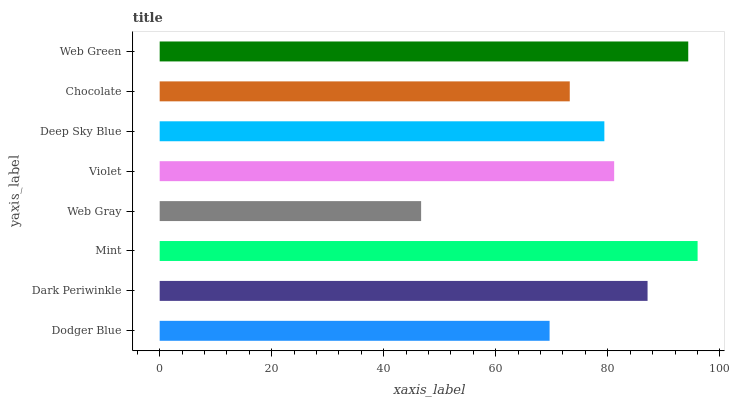Is Web Gray the minimum?
Answer yes or no. Yes. Is Mint the maximum?
Answer yes or no. Yes. Is Dark Periwinkle the minimum?
Answer yes or no. No. Is Dark Periwinkle the maximum?
Answer yes or no. No. Is Dark Periwinkle greater than Dodger Blue?
Answer yes or no. Yes. Is Dodger Blue less than Dark Periwinkle?
Answer yes or no. Yes. Is Dodger Blue greater than Dark Periwinkle?
Answer yes or no. No. Is Dark Periwinkle less than Dodger Blue?
Answer yes or no. No. Is Violet the high median?
Answer yes or no. Yes. Is Deep Sky Blue the low median?
Answer yes or no. Yes. Is Web Green the high median?
Answer yes or no. No. Is Web Green the low median?
Answer yes or no. No. 